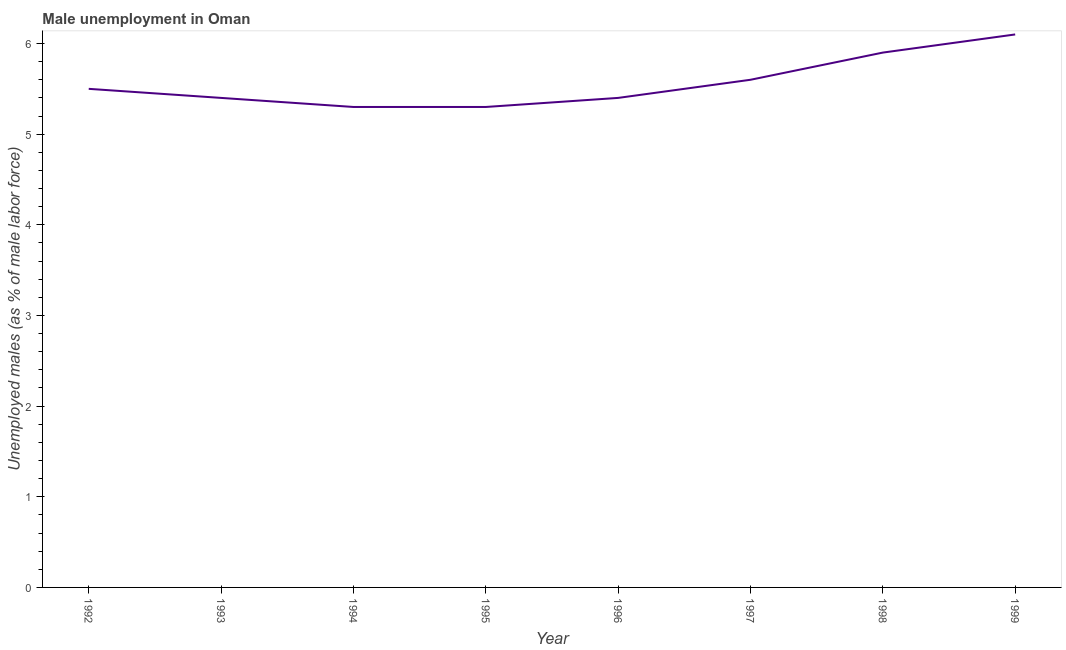What is the unemployed males population in 1999?
Your answer should be very brief. 6.1. Across all years, what is the maximum unemployed males population?
Provide a succinct answer. 6.1. Across all years, what is the minimum unemployed males population?
Your answer should be very brief. 5.3. What is the sum of the unemployed males population?
Give a very brief answer. 44.5. What is the difference between the unemployed males population in 1992 and 1998?
Ensure brevity in your answer.  -0.4. What is the average unemployed males population per year?
Give a very brief answer. 5.56. What is the median unemployed males population?
Provide a short and direct response. 5.45. In how many years, is the unemployed males population greater than 1 %?
Make the answer very short. 8. Do a majority of the years between 1994 and 1992 (inclusive) have unemployed males population greater than 5 %?
Your response must be concise. No. What is the ratio of the unemployed males population in 1995 to that in 1997?
Your answer should be very brief. 0.95. Is the difference between the unemployed males population in 1995 and 1998 greater than the difference between any two years?
Your answer should be compact. No. What is the difference between the highest and the second highest unemployed males population?
Keep it short and to the point. 0.2. What is the difference between the highest and the lowest unemployed males population?
Offer a terse response. 0.8. In how many years, is the unemployed males population greater than the average unemployed males population taken over all years?
Ensure brevity in your answer.  3. Does the unemployed males population monotonically increase over the years?
Provide a succinct answer. No. How many years are there in the graph?
Provide a succinct answer. 8. What is the difference between two consecutive major ticks on the Y-axis?
Give a very brief answer. 1. Are the values on the major ticks of Y-axis written in scientific E-notation?
Your response must be concise. No. Does the graph contain grids?
Keep it short and to the point. No. What is the title of the graph?
Make the answer very short. Male unemployment in Oman. What is the label or title of the X-axis?
Your answer should be compact. Year. What is the label or title of the Y-axis?
Offer a very short reply. Unemployed males (as % of male labor force). What is the Unemployed males (as % of male labor force) of 1993?
Your answer should be very brief. 5.4. What is the Unemployed males (as % of male labor force) in 1994?
Your response must be concise. 5.3. What is the Unemployed males (as % of male labor force) in 1995?
Give a very brief answer. 5.3. What is the Unemployed males (as % of male labor force) of 1996?
Keep it short and to the point. 5.4. What is the Unemployed males (as % of male labor force) in 1997?
Your answer should be compact. 5.6. What is the Unemployed males (as % of male labor force) in 1998?
Your answer should be very brief. 5.9. What is the Unemployed males (as % of male labor force) of 1999?
Make the answer very short. 6.1. What is the difference between the Unemployed males (as % of male labor force) in 1992 and 1993?
Ensure brevity in your answer.  0.1. What is the difference between the Unemployed males (as % of male labor force) in 1993 and 1994?
Make the answer very short. 0.1. What is the difference between the Unemployed males (as % of male labor force) in 1993 and 1995?
Your response must be concise. 0.1. What is the difference between the Unemployed males (as % of male labor force) in 1993 and 1996?
Your answer should be very brief. 0. What is the difference between the Unemployed males (as % of male labor force) in 1993 and 1997?
Provide a short and direct response. -0.2. What is the difference between the Unemployed males (as % of male labor force) in 1993 and 1998?
Offer a very short reply. -0.5. What is the difference between the Unemployed males (as % of male labor force) in 1993 and 1999?
Offer a terse response. -0.7. What is the difference between the Unemployed males (as % of male labor force) in 1994 and 1995?
Your response must be concise. 0. What is the difference between the Unemployed males (as % of male labor force) in 1994 and 1996?
Keep it short and to the point. -0.1. What is the difference between the Unemployed males (as % of male labor force) in 1994 and 1997?
Keep it short and to the point. -0.3. What is the difference between the Unemployed males (as % of male labor force) in 1994 and 1998?
Keep it short and to the point. -0.6. What is the difference between the Unemployed males (as % of male labor force) in 1995 and 1997?
Provide a succinct answer. -0.3. What is the difference between the Unemployed males (as % of male labor force) in 1995 and 1999?
Make the answer very short. -0.8. What is the difference between the Unemployed males (as % of male labor force) in 1996 and 1997?
Ensure brevity in your answer.  -0.2. What is the difference between the Unemployed males (as % of male labor force) in 1996 and 1999?
Give a very brief answer. -0.7. What is the difference between the Unemployed males (as % of male labor force) in 1998 and 1999?
Provide a succinct answer. -0.2. What is the ratio of the Unemployed males (as % of male labor force) in 1992 to that in 1993?
Your answer should be compact. 1.02. What is the ratio of the Unemployed males (as % of male labor force) in 1992 to that in 1994?
Your answer should be very brief. 1.04. What is the ratio of the Unemployed males (as % of male labor force) in 1992 to that in 1995?
Provide a succinct answer. 1.04. What is the ratio of the Unemployed males (as % of male labor force) in 1992 to that in 1998?
Provide a succinct answer. 0.93. What is the ratio of the Unemployed males (as % of male labor force) in 1992 to that in 1999?
Offer a very short reply. 0.9. What is the ratio of the Unemployed males (as % of male labor force) in 1993 to that in 1994?
Make the answer very short. 1.02. What is the ratio of the Unemployed males (as % of male labor force) in 1993 to that in 1996?
Your response must be concise. 1. What is the ratio of the Unemployed males (as % of male labor force) in 1993 to that in 1997?
Your response must be concise. 0.96. What is the ratio of the Unemployed males (as % of male labor force) in 1993 to that in 1998?
Ensure brevity in your answer.  0.92. What is the ratio of the Unemployed males (as % of male labor force) in 1993 to that in 1999?
Ensure brevity in your answer.  0.89. What is the ratio of the Unemployed males (as % of male labor force) in 1994 to that in 1995?
Your response must be concise. 1. What is the ratio of the Unemployed males (as % of male labor force) in 1994 to that in 1997?
Your answer should be very brief. 0.95. What is the ratio of the Unemployed males (as % of male labor force) in 1994 to that in 1998?
Ensure brevity in your answer.  0.9. What is the ratio of the Unemployed males (as % of male labor force) in 1994 to that in 1999?
Your answer should be compact. 0.87. What is the ratio of the Unemployed males (as % of male labor force) in 1995 to that in 1997?
Provide a succinct answer. 0.95. What is the ratio of the Unemployed males (as % of male labor force) in 1995 to that in 1998?
Your answer should be very brief. 0.9. What is the ratio of the Unemployed males (as % of male labor force) in 1995 to that in 1999?
Offer a very short reply. 0.87. What is the ratio of the Unemployed males (as % of male labor force) in 1996 to that in 1998?
Your answer should be very brief. 0.92. What is the ratio of the Unemployed males (as % of male labor force) in 1996 to that in 1999?
Provide a short and direct response. 0.89. What is the ratio of the Unemployed males (as % of male labor force) in 1997 to that in 1998?
Give a very brief answer. 0.95. What is the ratio of the Unemployed males (as % of male labor force) in 1997 to that in 1999?
Provide a succinct answer. 0.92. What is the ratio of the Unemployed males (as % of male labor force) in 1998 to that in 1999?
Offer a very short reply. 0.97. 